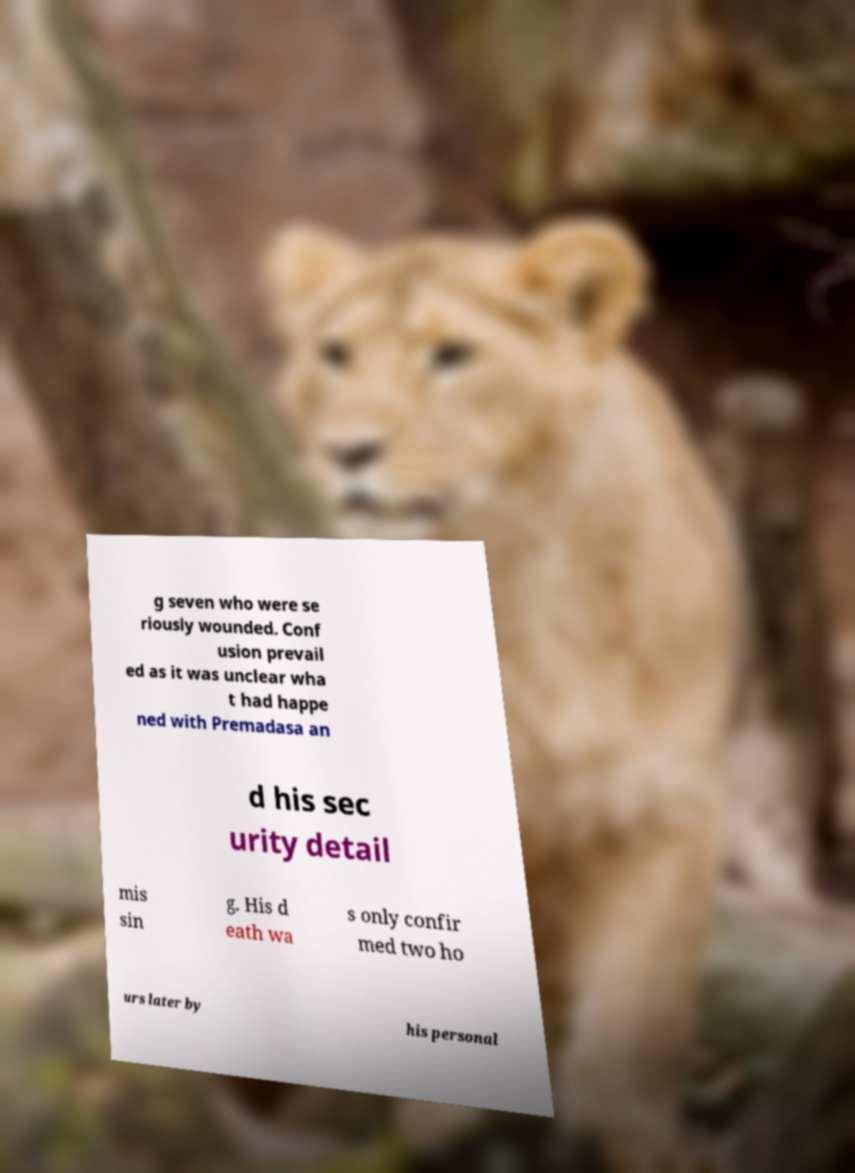Could you extract and type out the text from this image? g seven who were se riously wounded. Conf usion prevail ed as it was unclear wha t had happe ned with Premadasa an d his sec urity detail mis sin g. His d eath wa s only confir med two ho urs later by his personal 